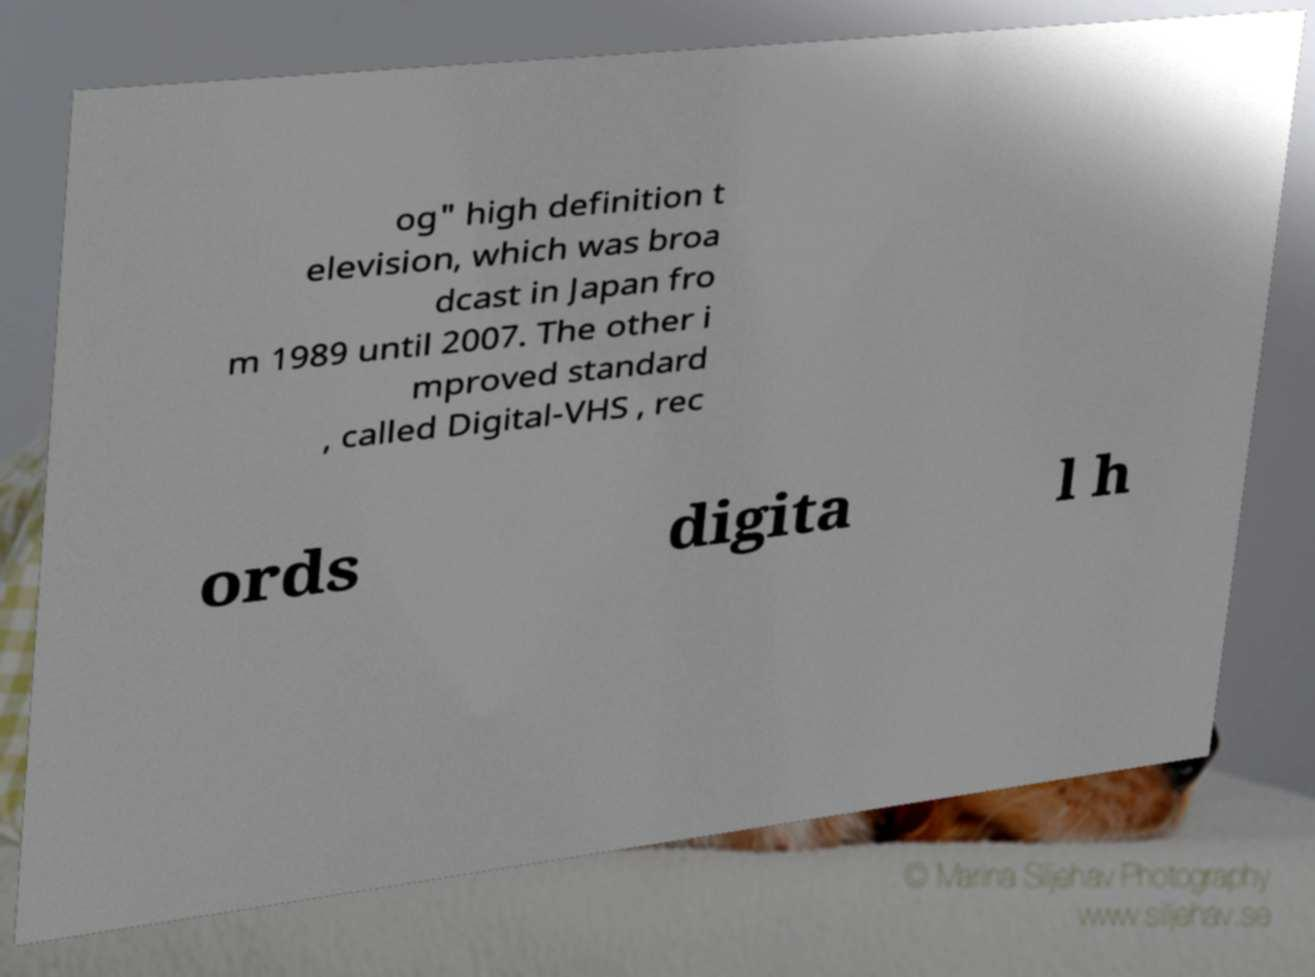For documentation purposes, I need the text within this image transcribed. Could you provide that? og" high definition t elevision, which was broa dcast in Japan fro m 1989 until 2007. The other i mproved standard , called Digital-VHS , rec ords digita l h 